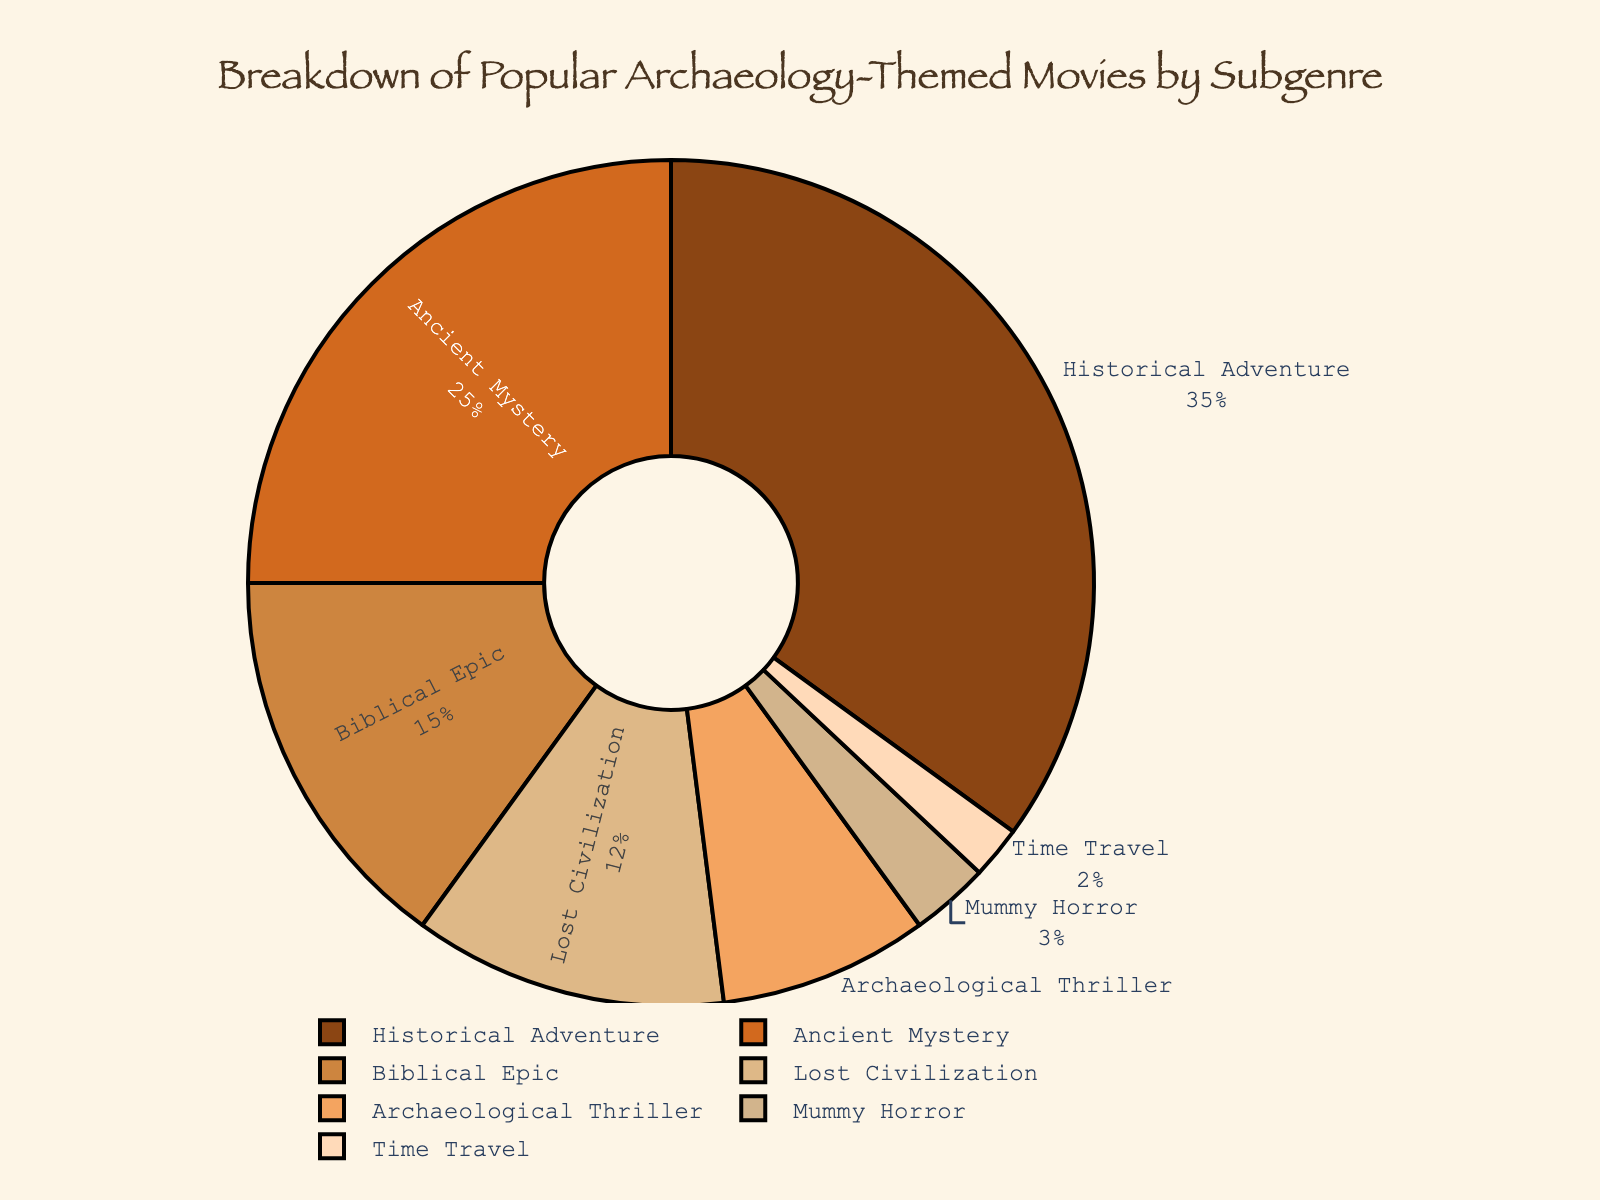Which subgenre has the highest percentage? The subgenre with the highest percentage is easily identifiable from the largest segment in the pie chart. This is the 'Historical Adventure' subgenre.
Answer: Historical Adventure How much larger is the 'Historical Adventure' segment compared to the 'Ancient Mystery' segment? The 'Historical Adventure' segment is 35%, and the 'Ancient Mystery' segment is 25%. The difference is 35% - 25% = 10%.
Answer: 10% Which two subgenres combined make up over 50% of the chart? To determine which two subgenres combined exceed 50%, observe the largest segments: 'Historical Adventure' (35%) and 'Ancient Mystery' (25%). Their sum is 35% + 25% = 60%, which is over 50%.
Answer: Historical Adventure and Ancient Mystery Is the percentage of 'Biblical Epic' greater than 'Lost Civilization' and 'Mummy Horror' combined? The percentage of 'Biblical Epic' is 15%. The combined percentage of 'Lost Civilization' (12%) and 'Mummy Horror' (3%) is 12% + 3% = 15%, which is equal to 'Biblical Epic' not greater.
Answer: No What is the combined percentage of the subgenres that make up less than 10% each? Adding the percentages of subgenres below 10%: Archaeological Thriller (8%), Mummy Horror (3%), and Time Travel (2%) gives 8% + 3% + 2% = 13%.
Answer: 13% What color represents the 'Lost Civilization' subgenre in the pie chart? The 'Lost Civilization' segment is represented by the fourth color from the left, which is the light brownish color.
Answer: Light brown Excluding the 'Historical Adventure' segment, what is the average percentage of the remaining subgenres? Excluding 'Historical Adventure' (35%): the remaining subgenres percentages are 25%, 15%, 12%, 8%, 3%, and 2%. Average = (25% + 15% + 12% + 8% + 3% + 2%) / 6 = 65% / 6 ≈ 10.83%.
Answer: 10.83% Which subgenre has the smallest representation in the chart? The smallest segment in the pie chart, which is 'Time Travel', represents only 2%.
Answer: Time Travel 